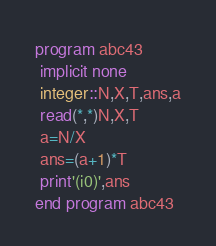Convert code to text. <code><loc_0><loc_0><loc_500><loc_500><_FORTRAN_>program abc43
 implicit none
 integer::N,X,T,ans,a
 read(*,*)N,X,T
 a=N/X
 ans=(a+1)*T
 print'(i0)',ans
end program abc43</code> 